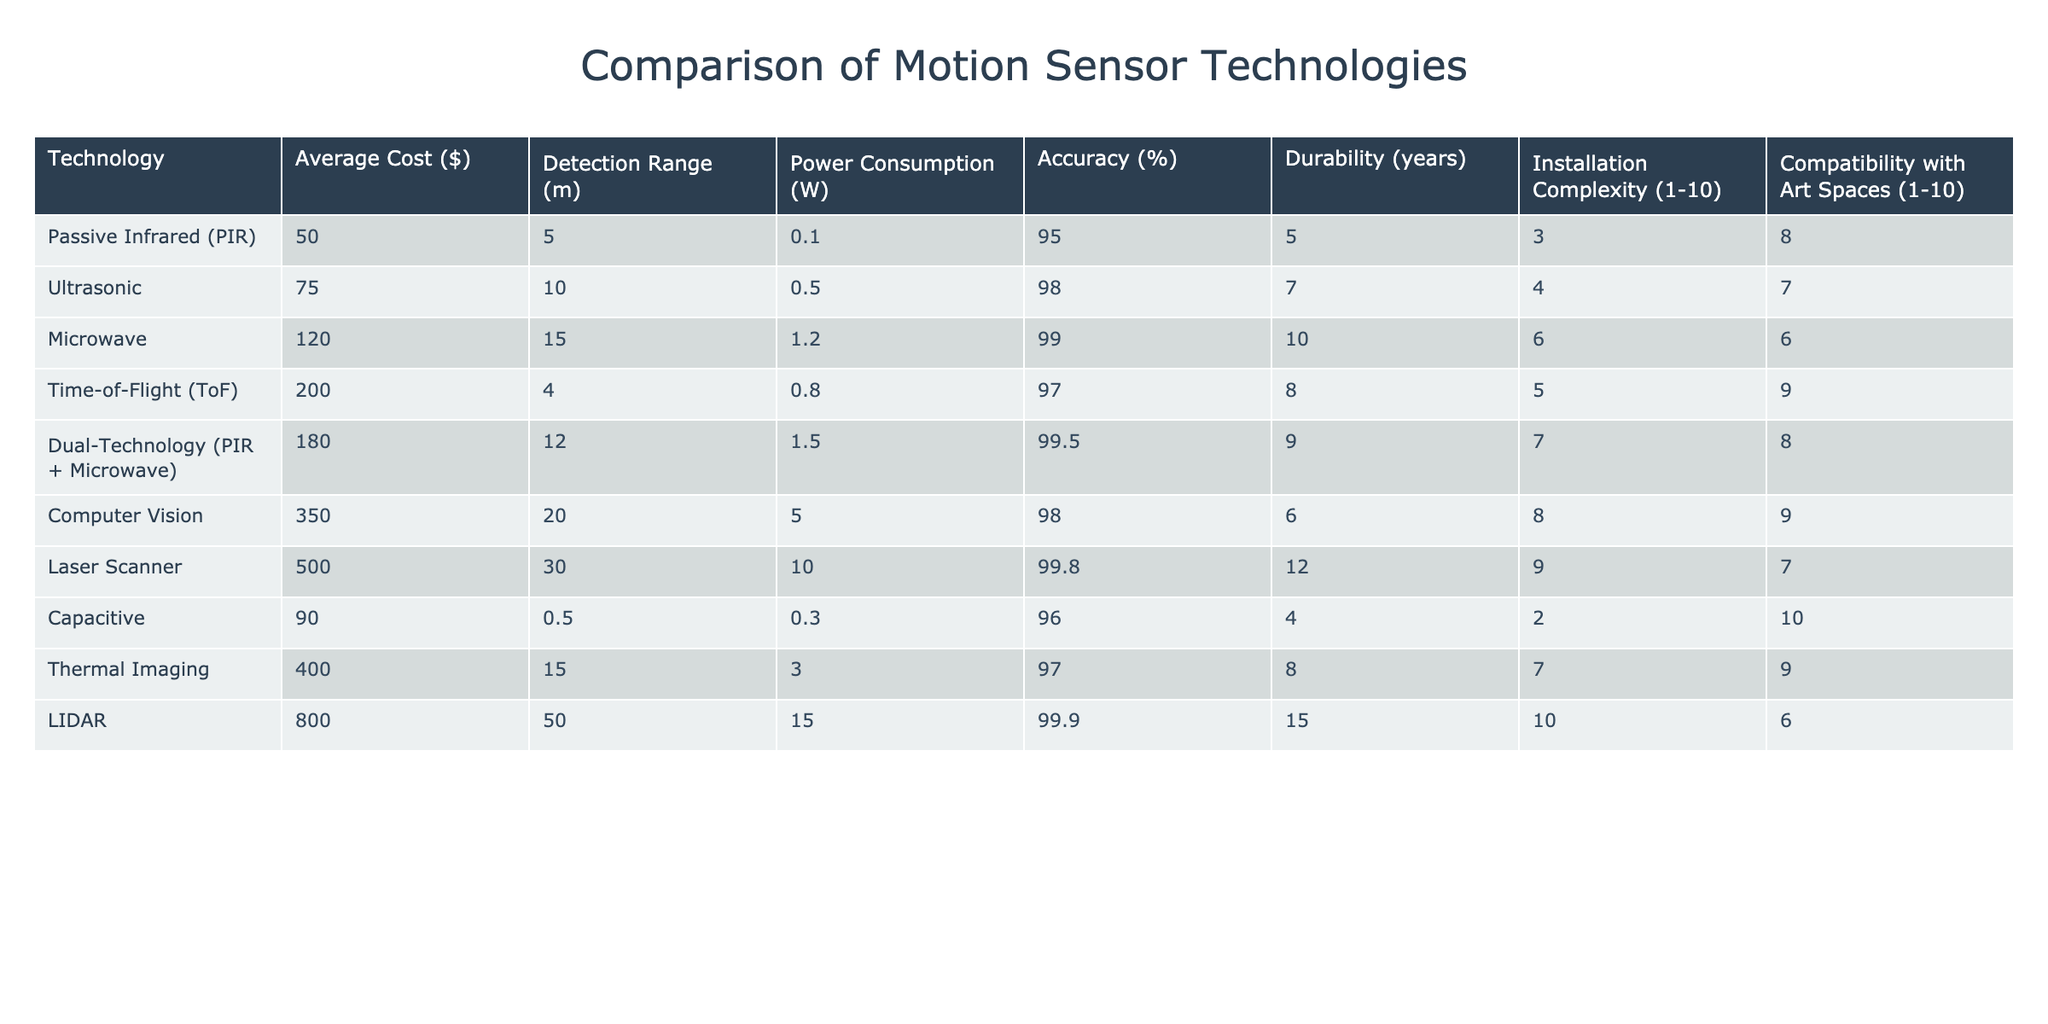What is the average cost of the motion sensor technologies listed? To find the average cost, we need to sum the costs of all technologies and then divide by the number of technologies. The sum of the costs is 50 + 75 + 120 + 200 + 180 + 350 + 500 + 90 + 400 + 800 = 2265. There are 10 technologies, so the average is 2265 / 10 = 226.5.
Answer: 226.5 Which motion sensor has the highest accuracy percentage? By examining the accuracy column, we see that LIDAR has an accuracy of 99.9%, which is the highest among all technologies listed.
Answer: LIDAR Is the installation complexity of Computer Vision greater than that of Thermal Imaging? Computer Vision has an installation complexity rating of 6 while Thermal Imaging has a rating of 7. Since 6 is not greater than 7, the statement is false.
Answer: No What is the average power consumption of all technologies? To find the average power consumption, sum all the power consumption values: 0.1 + 0.5 + 1.2 + 0.8 + 1.5 + 5 + 10 + 0.3 + 3 + 15 = 37.6. Dividing this by the number of technologies (10) gives us an average of 37.6 / 10 = 3.76.
Answer: 3.76 Which technology has the longest durability and how many years is it? Looking at the durability column, LIDAR has a durability of 15 years, which is the highest compared to all other technologies listed.
Answer: LIDAR, 15 years Is the Detection Range for Ultrasonic greater than that for Passive Infrared technologies? The detection range for Ultrasonic is 10 meters and for Passive Infrared is 5 meters. Since 10 is greater than 5, the statement is true.
Answer: Yes What is the least expensive technology with a power consumption of less than 1 watt? First, filter technologies with power consumption below 1 watt: PIR (0.1), Ultrasonic (0.5), Capacitive (0.3), and Time-of-Flight (0.8). Among these, the least expensive is PIR, which costs $50.
Answer: PIR, $50 If we only consider technologies with an installation complexity of 5 or less, what is the average accuracy? The technologies that match this criterion are PIR (95%), Ultrasonic (98%), and Capacitive (96%). Their total accuracy is 95 + 98 + 96 = 289. Dividing this by the number of technologies (3) gives an average of 289 / 3 = 96.33.
Answer: 96.33 What technology has the best compatibility with art spaces and what is its score? Examining the compatibility column shows that Capacitive has the best compatibility score of 10, which is the highest.
Answer: Capacitive, 10 